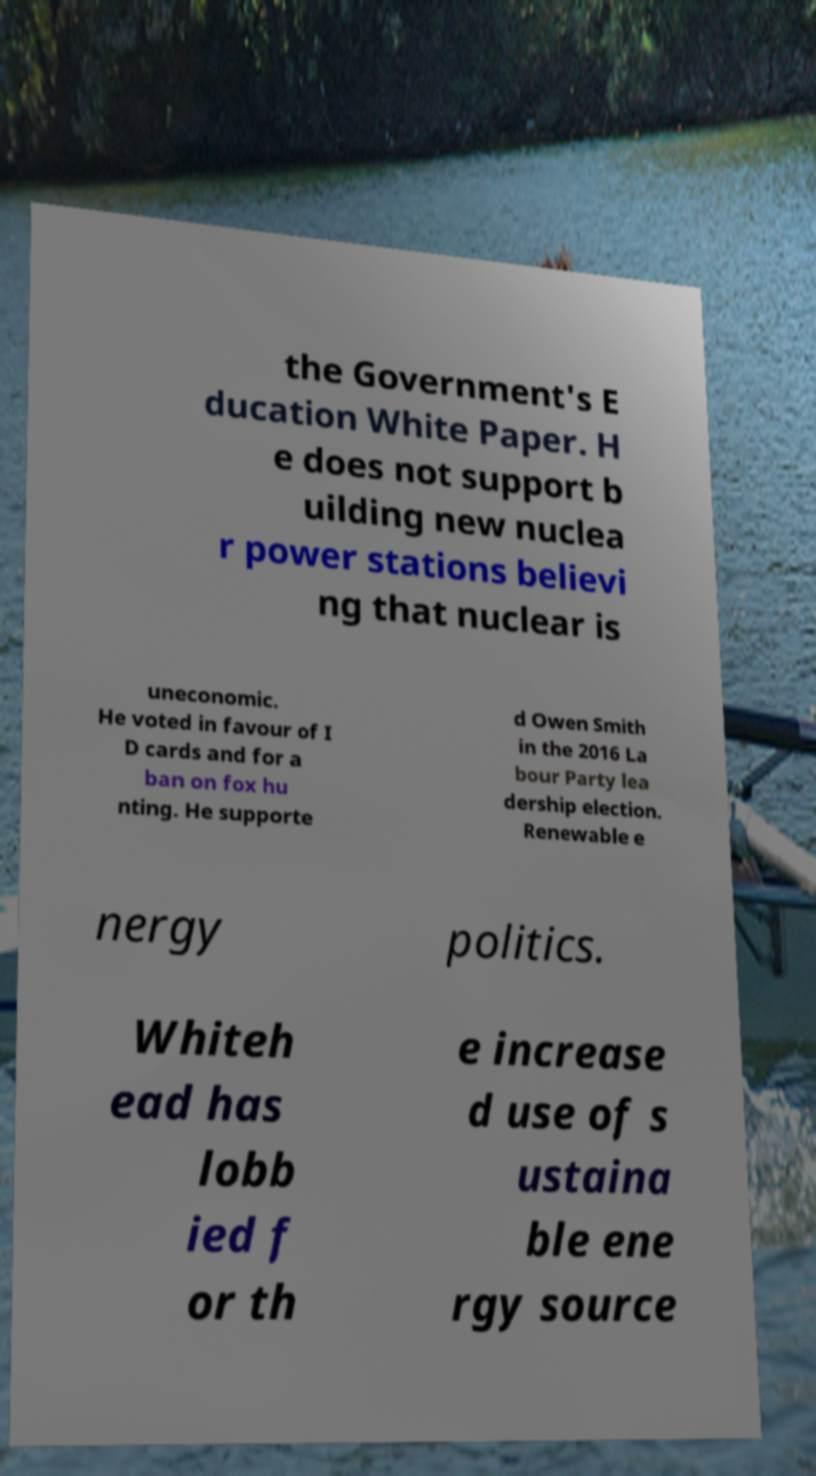There's text embedded in this image that I need extracted. Can you transcribe it verbatim? the Government's E ducation White Paper. H e does not support b uilding new nuclea r power stations believi ng that nuclear is uneconomic. He voted in favour of I D cards and for a ban on fox hu nting. He supporte d Owen Smith in the 2016 La bour Party lea dership election. Renewable e nergy politics. Whiteh ead has lobb ied f or th e increase d use of s ustaina ble ene rgy source 